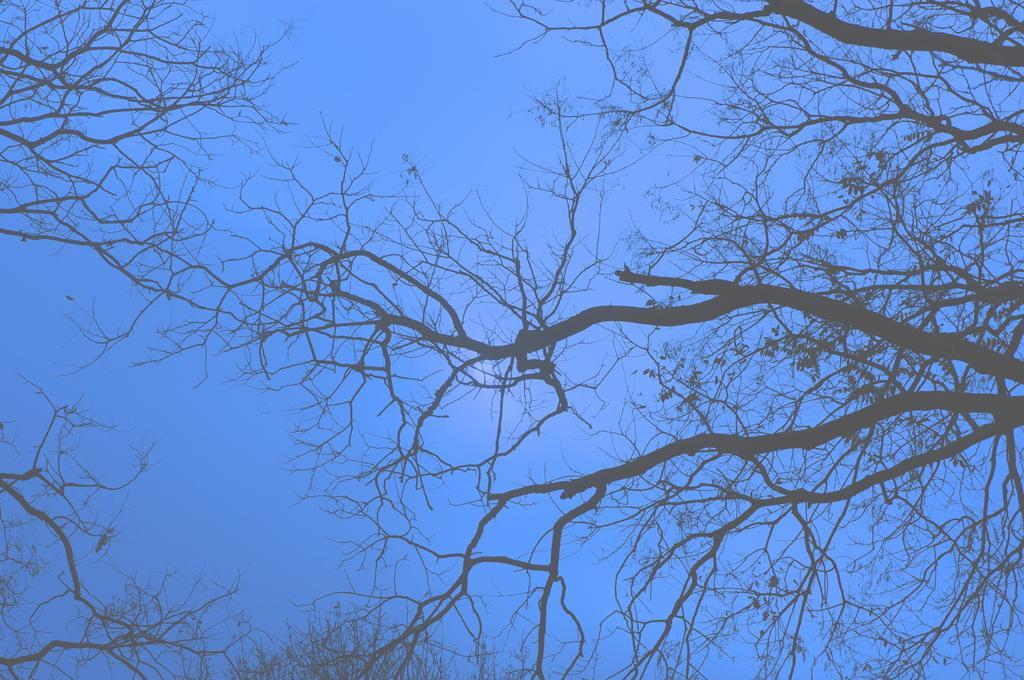Describe this image in one or two sentences. In this image, we can see some branches. In the background of the image, there is a sky. 